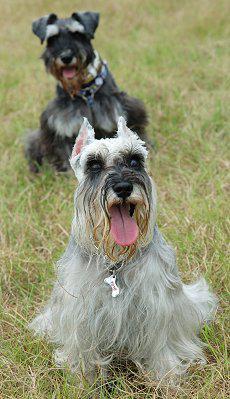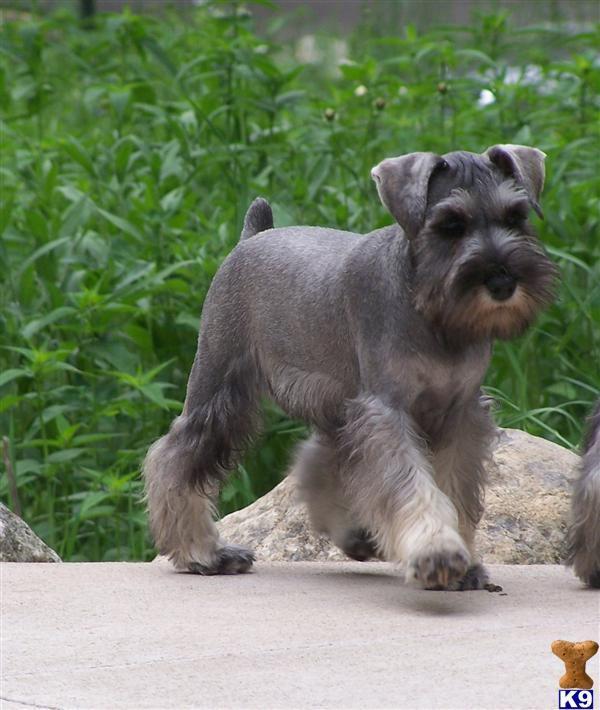The first image is the image on the left, the second image is the image on the right. Given the left and right images, does the statement "At least one image is a solo black dog." hold true? Answer yes or no. No. 